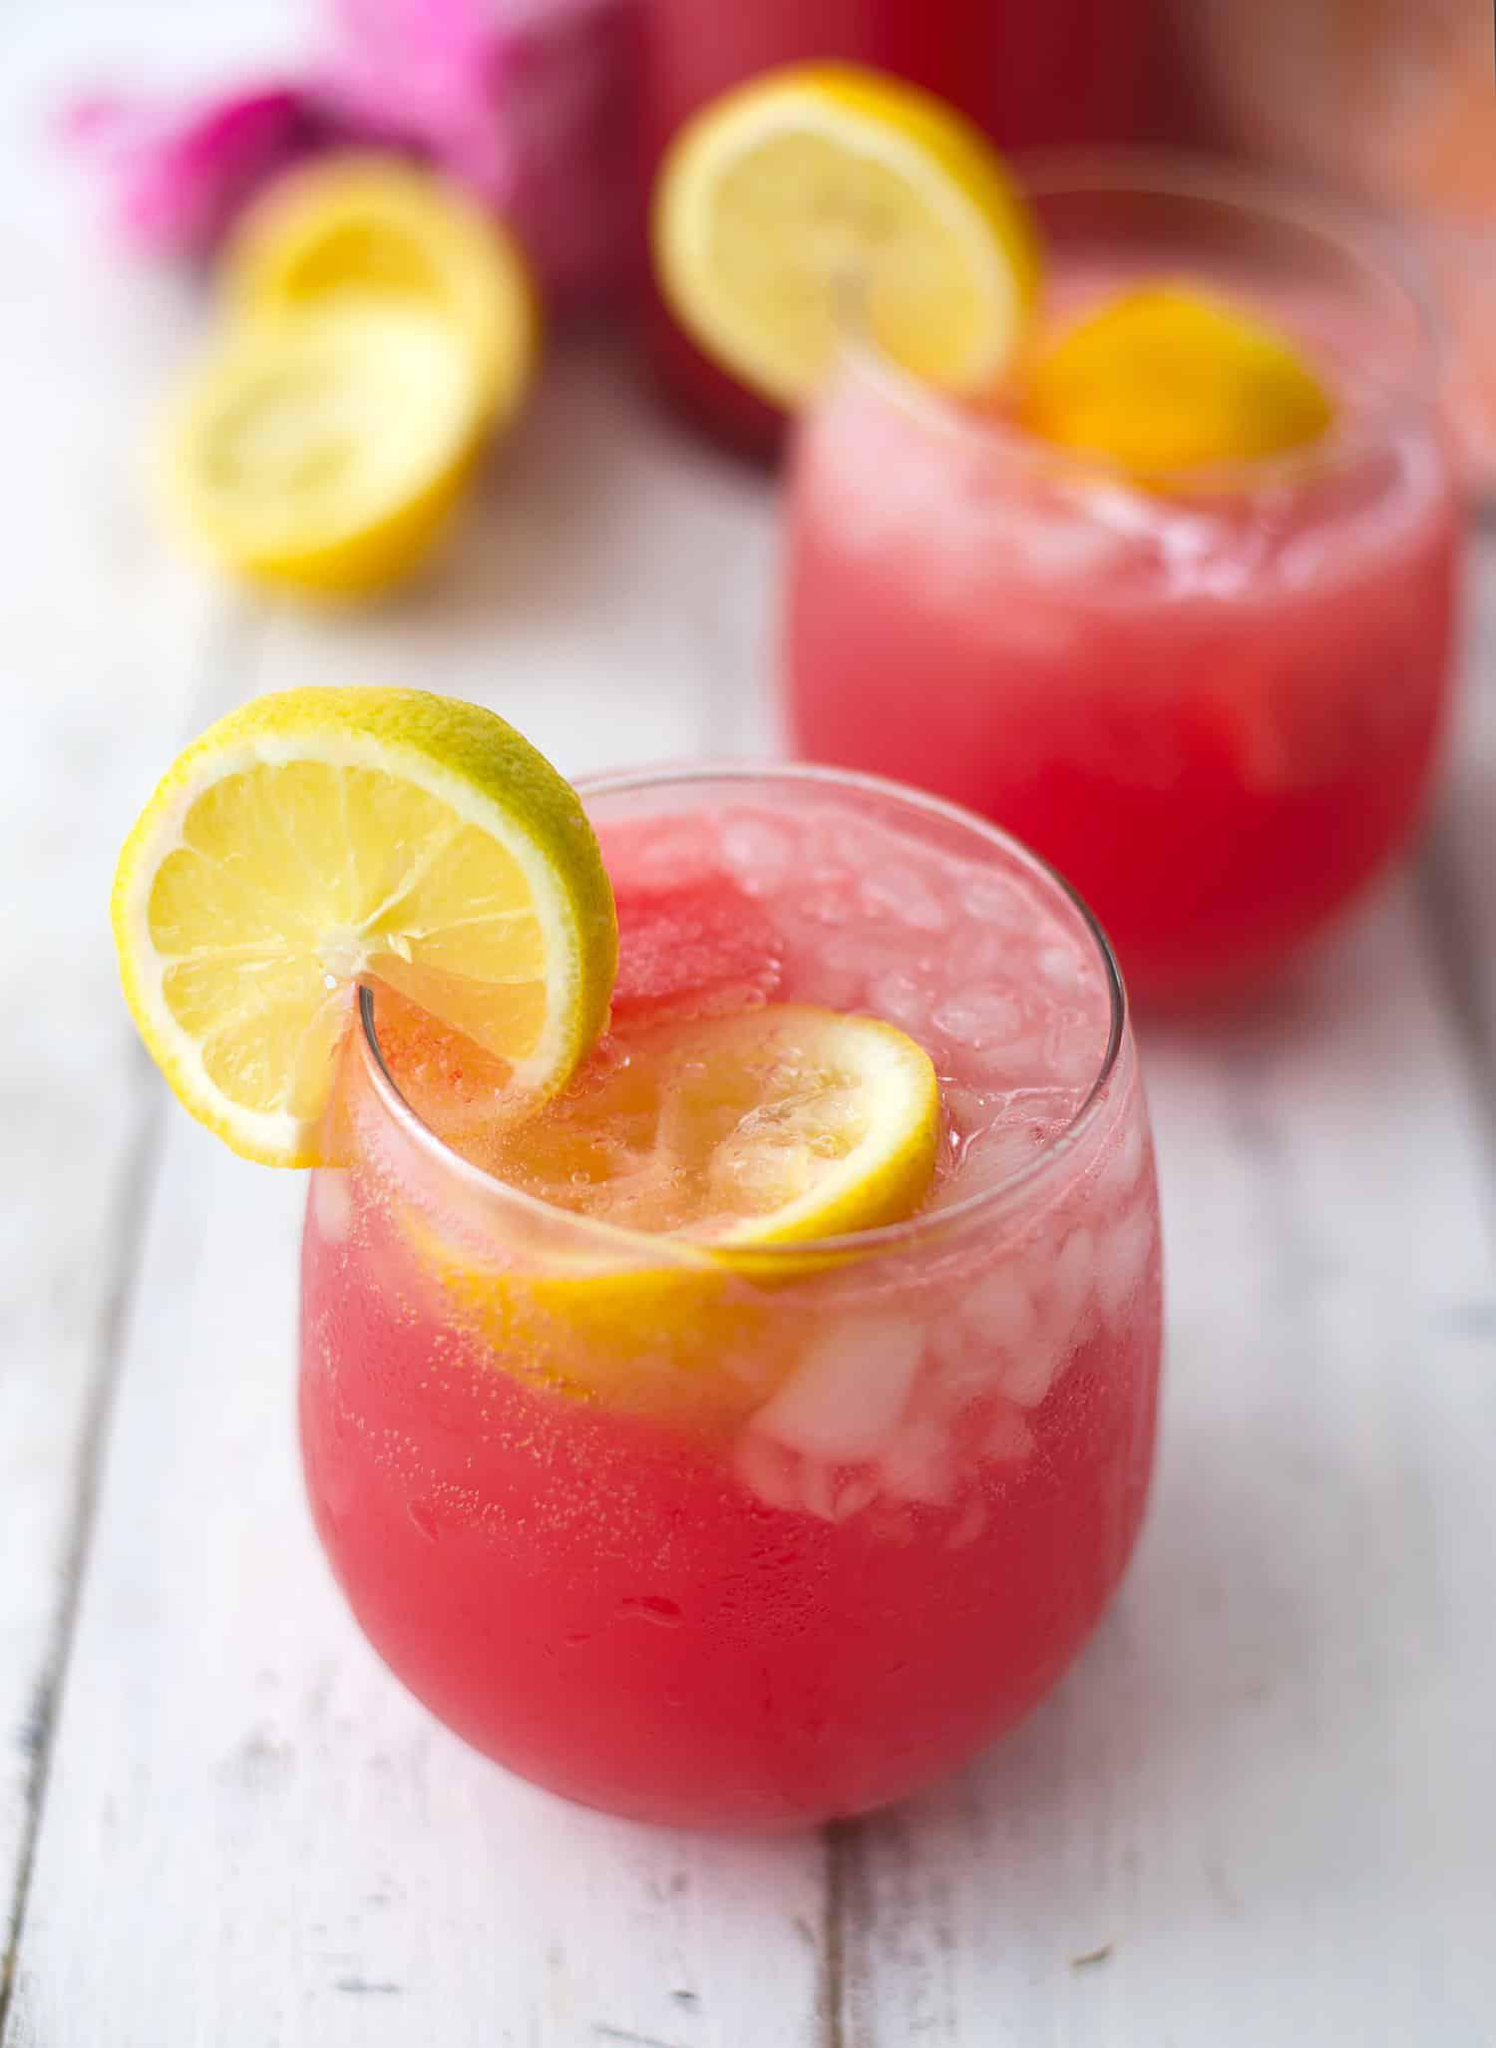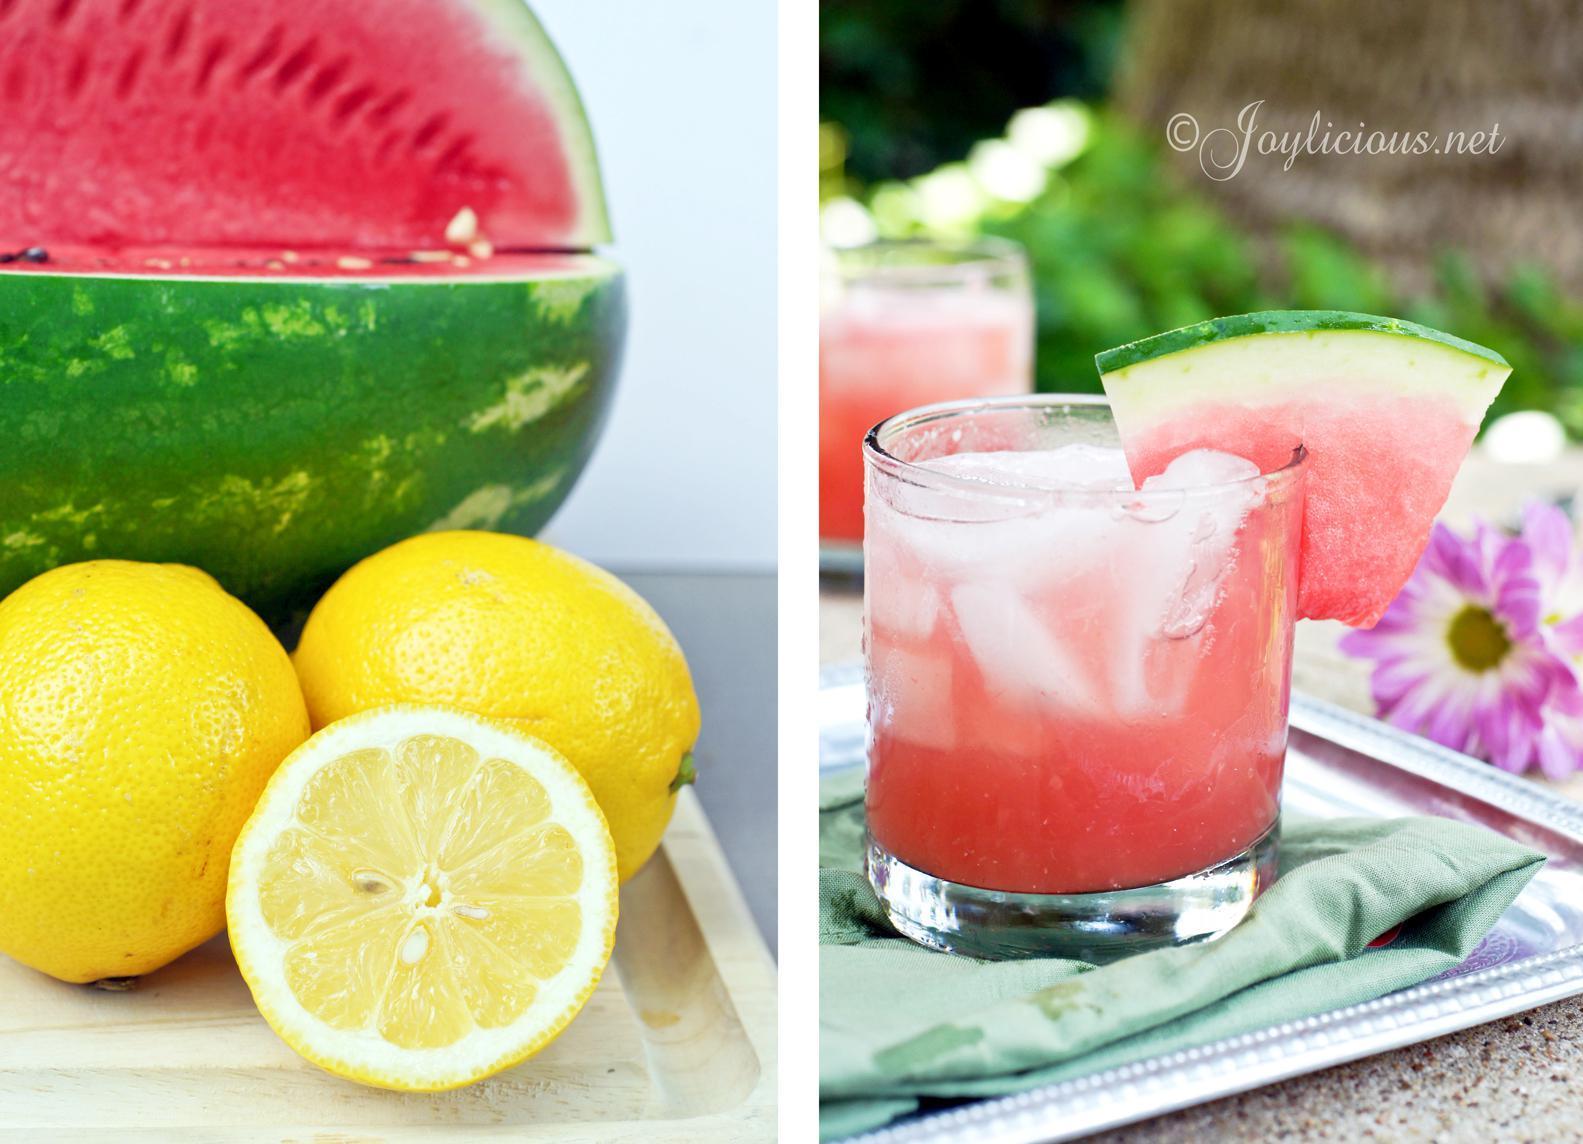The first image is the image on the left, the second image is the image on the right. For the images displayed, is the sentence "The liquid in the glass is pink and garnished with fruit." factually correct? Answer yes or no. Yes. The first image is the image on the left, the second image is the image on the right. Examine the images to the left and right. Is the description "At least one small pink drink with a garnish of lemon or watermelon is seen in each image." accurate? Answer yes or no. Yes. The first image is the image on the left, the second image is the image on the right. For the images shown, is this caption "In one image, glasses are garnished with lemon pieces." true? Answer yes or no. Yes. 